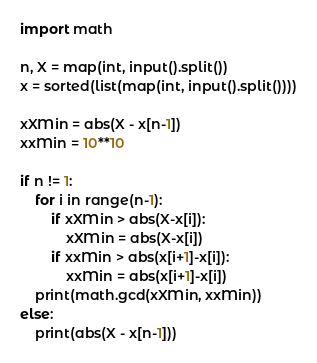Convert code to text. <code><loc_0><loc_0><loc_500><loc_500><_Python_>import math

n, X = map(int, input().split())
x = sorted(list(map(int, input().split())))

xXMin = abs(X - x[n-1])
xxMin = 10**10

if n != 1:
    for i in range(n-1):
        if xXMin > abs(X-x[i]):
            xXMin = abs(X-x[i])
        if xxMin > abs(x[i+1]-x[i]):
            xxMin = abs(x[i+1]-x[i])
    print(math.gcd(xXMin, xxMin))
else:
    print(abs(X - x[n-1]))
</code> 